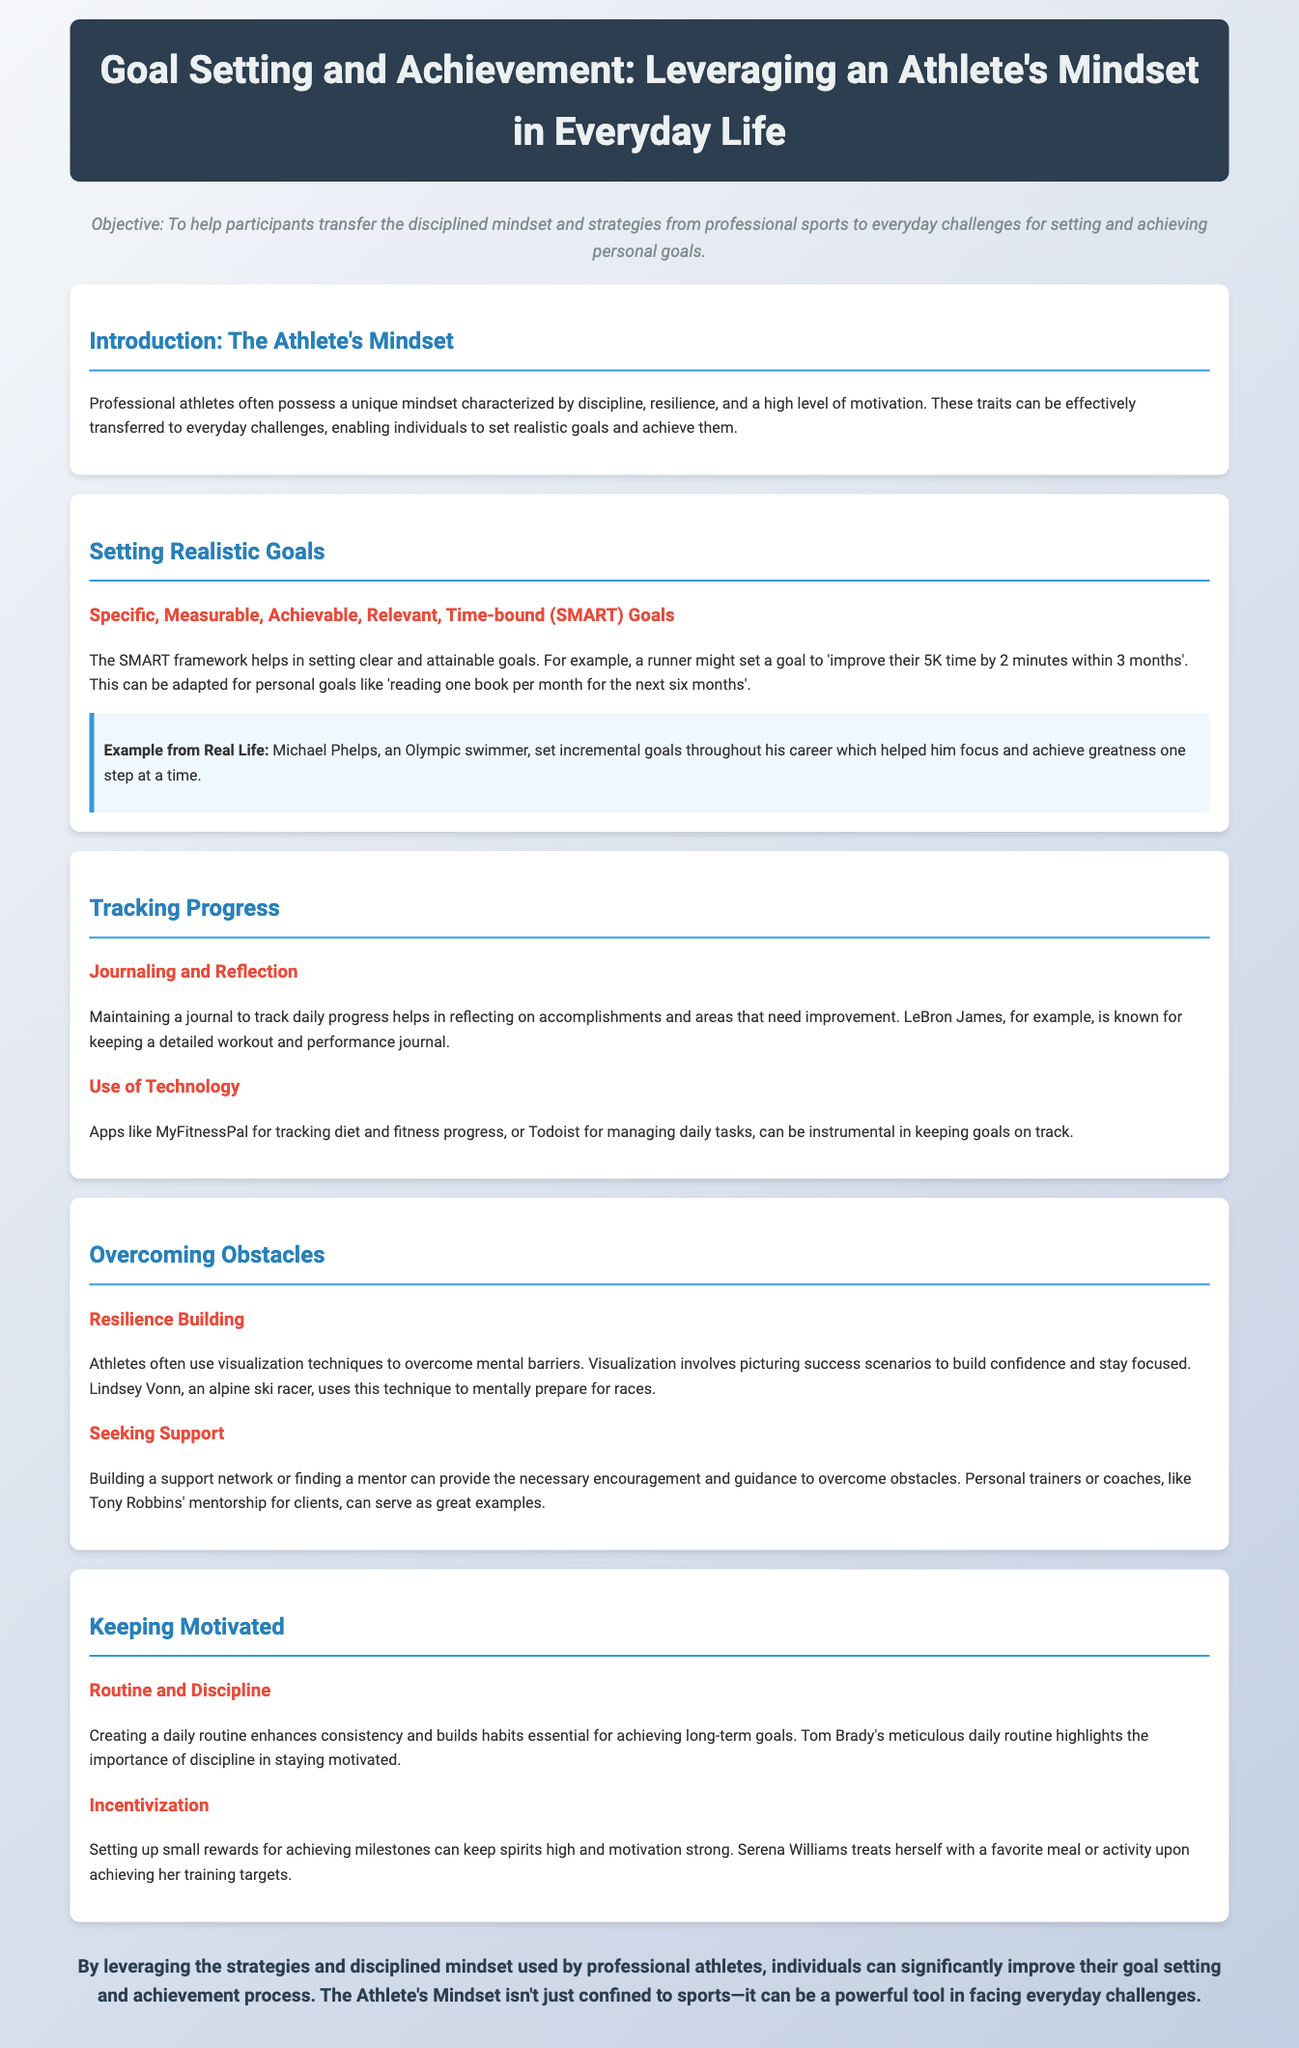What is the main objective of the lesson plan? The objective is to help participants transfer the disciplined mindset and strategies from professional sports to everyday challenges for setting and achieving personal goals.
Answer: To help participants transfer the disciplined mindset and strategies from professional sports to everyday challenges for setting and achieving personal goals What does SMART stand for? SMART is an acronym that defines the criteria for setting clear and attainable goals: Specific, Measurable, Achievable, Relevant, Time-bound.
Answer: Specific, Measurable, Achievable, Relevant, Time-bound Who is mentioned as an example of setting incremental goals? Michael Phelps is highlighted as an example of someone who set incremental goals throughout his career.
Answer: Michael Phelps What technique is suggested for overcoming mental barriers? Visualization techniques are recommended for overcoming mental barriers.
Answer: Visualization techniques Which app is mentioned for tracking diet and fitness progress? MyFitnessPal is mentioned as an app for tracking diet and fitness progress.
Answer: MyFitnessPal What routine aspect is highlighted for keeping motivated? Creating a daily routine is emphasized as a factor for enhancing consistency and building habits.
Answer: Creating a daily routine What small reward does Serena Williams use to maintain motivation? Serena Williams treats herself with a favorite meal or activity upon achieving her training targets.
Answer: A favorite meal or activity Which professional athlete’s routine is mentioned to highlight the importance of discipline? Tom Brady's meticulous daily routine is mentioned to illustrate the importance of discipline.
Answer: Tom Brady What is one method to track daily progress suggested in the document? Maintaining a journal to track daily progress is one method suggested.
Answer: Maintaining a journal 